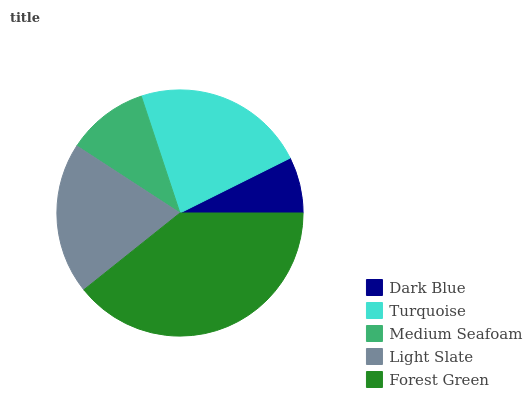Is Dark Blue the minimum?
Answer yes or no. Yes. Is Forest Green the maximum?
Answer yes or no. Yes. Is Turquoise the minimum?
Answer yes or no. No. Is Turquoise the maximum?
Answer yes or no. No. Is Turquoise greater than Dark Blue?
Answer yes or no. Yes. Is Dark Blue less than Turquoise?
Answer yes or no. Yes. Is Dark Blue greater than Turquoise?
Answer yes or no. No. Is Turquoise less than Dark Blue?
Answer yes or no. No. Is Light Slate the high median?
Answer yes or no. Yes. Is Light Slate the low median?
Answer yes or no. Yes. Is Turquoise the high median?
Answer yes or no. No. Is Dark Blue the low median?
Answer yes or no. No. 